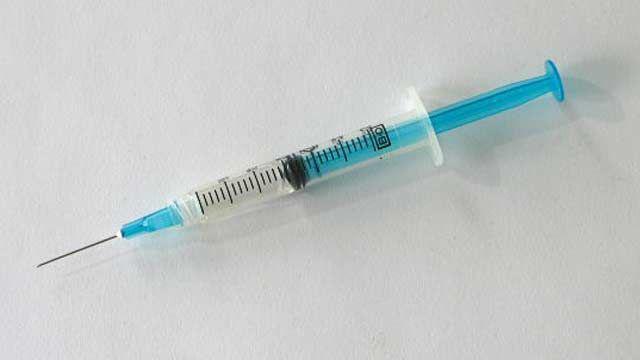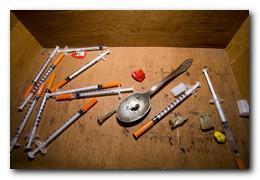The first image is the image on the left, the second image is the image on the right. Evaluate the accuracy of this statement regarding the images: "The image on the left contains exactly one syringe with an orange cap.". Is it true? Answer yes or no. No. The first image is the image on the left, the second image is the image on the right. Examine the images to the left and right. Is the description "An image shows only one syringe, and its needle is exposed." accurate? Answer yes or no. Yes. 